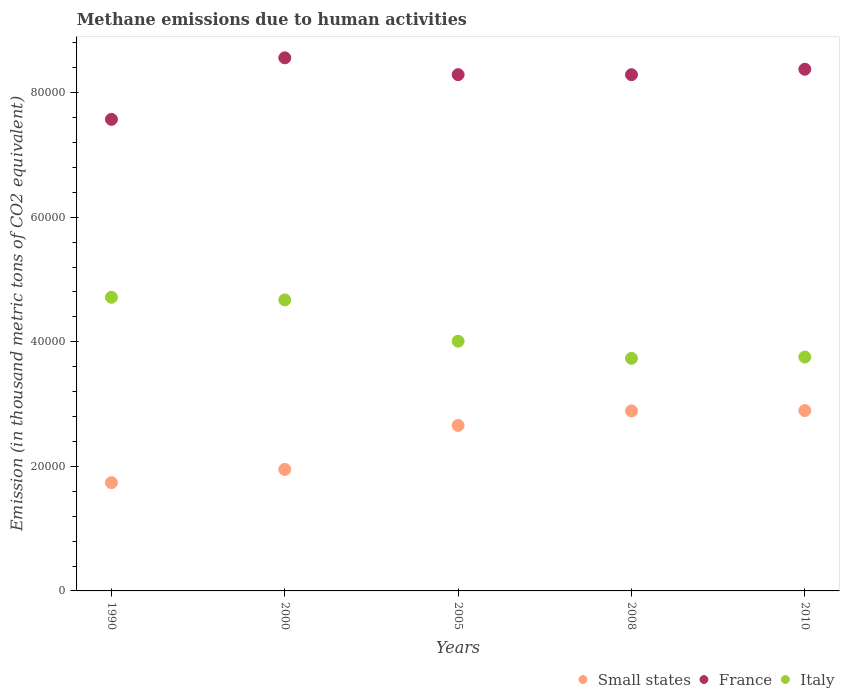How many different coloured dotlines are there?
Your answer should be compact. 3. Is the number of dotlines equal to the number of legend labels?
Keep it short and to the point. Yes. What is the amount of methane emitted in France in 2010?
Provide a short and direct response. 8.38e+04. Across all years, what is the maximum amount of methane emitted in Small states?
Give a very brief answer. 2.90e+04. Across all years, what is the minimum amount of methane emitted in Italy?
Provide a succinct answer. 3.73e+04. In which year was the amount of methane emitted in France maximum?
Provide a short and direct response. 2000. In which year was the amount of methane emitted in Small states minimum?
Offer a terse response. 1990. What is the total amount of methane emitted in Italy in the graph?
Your answer should be compact. 2.09e+05. What is the difference between the amount of methane emitted in France in 2000 and that in 2008?
Provide a succinct answer. 2710.3. What is the difference between the amount of methane emitted in Small states in 2005 and the amount of methane emitted in Italy in 2000?
Keep it short and to the point. -2.02e+04. What is the average amount of methane emitted in Italy per year?
Ensure brevity in your answer.  4.18e+04. In the year 1990, what is the difference between the amount of methane emitted in Italy and amount of methane emitted in France?
Make the answer very short. -2.86e+04. What is the ratio of the amount of methane emitted in Italy in 2000 to that in 2008?
Your answer should be compact. 1.25. Is the amount of methane emitted in France in 1990 less than that in 2010?
Provide a short and direct response. Yes. Is the difference between the amount of methane emitted in Italy in 1990 and 2008 greater than the difference between the amount of methane emitted in France in 1990 and 2008?
Offer a very short reply. Yes. What is the difference between the highest and the second highest amount of methane emitted in France?
Make the answer very short. 1835.2. What is the difference between the highest and the lowest amount of methane emitted in Small states?
Your answer should be compact. 1.16e+04. Is it the case that in every year, the sum of the amount of methane emitted in Italy and amount of methane emitted in France  is greater than the amount of methane emitted in Small states?
Give a very brief answer. Yes. Does the amount of methane emitted in France monotonically increase over the years?
Provide a short and direct response. No. Is the amount of methane emitted in France strictly less than the amount of methane emitted in Italy over the years?
Your answer should be very brief. No. How many dotlines are there?
Keep it short and to the point. 3. Does the graph contain grids?
Ensure brevity in your answer.  No. What is the title of the graph?
Keep it short and to the point. Methane emissions due to human activities. What is the label or title of the Y-axis?
Offer a very short reply. Emission (in thousand metric tons of CO2 equivalent). What is the Emission (in thousand metric tons of CO2 equivalent) in Small states in 1990?
Provide a short and direct response. 1.74e+04. What is the Emission (in thousand metric tons of CO2 equivalent) in France in 1990?
Provide a short and direct response. 7.57e+04. What is the Emission (in thousand metric tons of CO2 equivalent) of Italy in 1990?
Offer a terse response. 4.71e+04. What is the Emission (in thousand metric tons of CO2 equivalent) in Small states in 2000?
Make the answer very short. 1.95e+04. What is the Emission (in thousand metric tons of CO2 equivalent) in France in 2000?
Make the answer very short. 8.56e+04. What is the Emission (in thousand metric tons of CO2 equivalent) in Italy in 2000?
Your response must be concise. 4.67e+04. What is the Emission (in thousand metric tons of CO2 equivalent) in Small states in 2005?
Ensure brevity in your answer.  2.66e+04. What is the Emission (in thousand metric tons of CO2 equivalent) of France in 2005?
Keep it short and to the point. 8.29e+04. What is the Emission (in thousand metric tons of CO2 equivalent) in Italy in 2005?
Provide a short and direct response. 4.01e+04. What is the Emission (in thousand metric tons of CO2 equivalent) of Small states in 2008?
Ensure brevity in your answer.  2.89e+04. What is the Emission (in thousand metric tons of CO2 equivalent) of France in 2008?
Ensure brevity in your answer.  8.29e+04. What is the Emission (in thousand metric tons of CO2 equivalent) in Italy in 2008?
Offer a very short reply. 3.73e+04. What is the Emission (in thousand metric tons of CO2 equivalent) in Small states in 2010?
Keep it short and to the point. 2.90e+04. What is the Emission (in thousand metric tons of CO2 equivalent) in France in 2010?
Offer a very short reply. 8.38e+04. What is the Emission (in thousand metric tons of CO2 equivalent) in Italy in 2010?
Ensure brevity in your answer.  3.75e+04. Across all years, what is the maximum Emission (in thousand metric tons of CO2 equivalent) of Small states?
Keep it short and to the point. 2.90e+04. Across all years, what is the maximum Emission (in thousand metric tons of CO2 equivalent) in France?
Your answer should be very brief. 8.56e+04. Across all years, what is the maximum Emission (in thousand metric tons of CO2 equivalent) in Italy?
Provide a succinct answer. 4.71e+04. Across all years, what is the minimum Emission (in thousand metric tons of CO2 equivalent) in Small states?
Provide a succinct answer. 1.74e+04. Across all years, what is the minimum Emission (in thousand metric tons of CO2 equivalent) in France?
Provide a succinct answer. 7.57e+04. Across all years, what is the minimum Emission (in thousand metric tons of CO2 equivalent) in Italy?
Provide a short and direct response. 3.73e+04. What is the total Emission (in thousand metric tons of CO2 equivalent) in Small states in the graph?
Offer a very short reply. 1.21e+05. What is the total Emission (in thousand metric tons of CO2 equivalent) of France in the graph?
Provide a short and direct response. 4.11e+05. What is the total Emission (in thousand metric tons of CO2 equivalent) of Italy in the graph?
Your response must be concise. 2.09e+05. What is the difference between the Emission (in thousand metric tons of CO2 equivalent) in Small states in 1990 and that in 2000?
Offer a terse response. -2132.9. What is the difference between the Emission (in thousand metric tons of CO2 equivalent) of France in 1990 and that in 2000?
Your answer should be compact. -9878.9. What is the difference between the Emission (in thousand metric tons of CO2 equivalent) in Italy in 1990 and that in 2000?
Provide a short and direct response. 418.9. What is the difference between the Emission (in thousand metric tons of CO2 equivalent) in Small states in 1990 and that in 2005?
Give a very brief answer. -9189.8. What is the difference between the Emission (in thousand metric tons of CO2 equivalent) of France in 1990 and that in 2005?
Make the answer very short. -7175.9. What is the difference between the Emission (in thousand metric tons of CO2 equivalent) in Italy in 1990 and that in 2005?
Offer a very short reply. 7054.5. What is the difference between the Emission (in thousand metric tons of CO2 equivalent) in Small states in 1990 and that in 2008?
Make the answer very short. -1.15e+04. What is the difference between the Emission (in thousand metric tons of CO2 equivalent) in France in 1990 and that in 2008?
Your answer should be compact. -7168.6. What is the difference between the Emission (in thousand metric tons of CO2 equivalent) of Italy in 1990 and that in 2008?
Keep it short and to the point. 9804.1. What is the difference between the Emission (in thousand metric tons of CO2 equivalent) in Small states in 1990 and that in 2010?
Provide a short and direct response. -1.16e+04. What is the difference between the Emission (in thousand metric tons of CO2 equivalent) in France in 1990 and that in 2010?
Your response must be concise. -8043.7. What is the difference between the Emission (in thousand metric tons of CO2 equivalent) in Italy in 1990 and that in 2010?
Offer a very short reply. 9595.9. What is the difference between the Emission (in thousand metric tons of CO2 equivalent) in Small states in 2000 and that in 2005?
Your answer should be very brief. -7056.9. What is the difference between the Emission (in thousand metric tons of CO2 equivalent) in France in 2000 and that in 2005?
Your answer should be compact. 2703. What is the difference between the Emission (in thousand metric tons of CO2 equivalent) in Italy in 2000 and that in 2005?
Ensure brevity in your answer.  6635.6. What is the difference between the Emission (in thousand metric tons of CO2 equivalent) of Small states in 2000 and that in 2008?
Keep it short and to the point. -9393.1. What is the difference between the Emission (in thousand metric tons of CO2 equivalent) of France in 2000 and that in 2008?
Your answer should be very brief. 2710.3. What is the difference between the Emission (in thousand metric tons of CO2 equivalent) in Italy in 2000 and that in 2008?
Your answer should be compact. 9385.2. What is the difference between the Emission (in thousand metric tons of CO2 equivalent) of Small states in 2000 and that in 2010?
Keep it short and to the point. -9444.8. What is the difference between the Emission (in thousand metric tons of CO2 equivalent) of France in 2000 and that in 2010?
Your answer should be very brief. 1835.2. What is the difference between the Emission (in thousand metric tons of CO2 equivalent) of Italy in 2000 and that in 2010?
Ensure brevity in your answer.  9177. What is the difference between the Emission (in thousand metric tons of CO2 equivalent) in Small states in 2005 and that in 2008?
Ensure brevity in your answer.  -2336.2. What is the difference between the Emission (in thousand metric tons of CO2 equivalent) in France in 2005 and that in 2008?
Keep it short and to the point. 7.3. What is the difference between the Emission (in thousand metric tons of CO2 equivalent) in Italy in 2005 and that in 2008?
Make the answer very short. 2749.6. What is the difference between the Emission (in thousand metric tons of CO2 equivalent) of Small states in 2005 and that in 2010?
Give a very brief answer. -2387.9. What is the difference between the Emission (in thousand metric tons of CO2 equivalent) of France in 2005 and that in 2010?
Make the answer very short. -867.8. What is the difference between the Emission (in thousand metric tons of CO2 equivalent) of Italy in 2005 and that in 2010?
Give a very brief answer. 2541.4. What is the difference between the Emission (in thousand metric tons of CO2 equivalent) in Small states in 2008 and that in 2010?
Give a very brief answer. -51.7. What is the difference between the Emission (in thousand metric tons of CO2 equivalent) in France in 2008 and that in 2010?
Ensure brevity in your answer.  -875.1. What is the difference between the Emission (in thousand metric tons of CO2 equivalent) of Italy in 2008 and that in 2010?
Offer a very short reply. -208.2. What is the difference between the Emission (in thousand metric tons of CO2 equivalent) of Small states in 1990 and the Emission (in thousand metric tons of CO2 equivalent) of France in 2000?
Make the answer very short. -6.82e+04. What is the difference between the Emission (in thousand metric tons of CO2 equivalent) in Small states in 1990 and the Emission (in thousand metric tons of CO2 equivalent) in Italy in 2000?
Offer a terse response. -2.93e+04. What is the difference between the Emission (in thousand metric tons of CO2 equivalent) in France in 1990 and the Emission (in thousand metric tons of CO2 equivalent) in Italy in 2000?
Offer a terse response. 2.90e+04. What is the difference between the Emission (in thousand metric tons of CO2 equivalent) in Small states in 1990 and the Emission (in thousand metric tons of CO2 equivalent) in France in 2005?
Offer a very short reply. -6.55e+04. What is the difference between the Emission (in thousand metric tons of CO2 equivalent) of Small states in 1990 and the Emission (in thousand metric tons of CO2 equivalent) of Italy in 2005?
Keep it short and to the point. -2.27e+04. What is the difference between the Emission (in thousand metric tons of CO2 equivalent) in France in 1990 and the Emission (in thousand metric tons of CO2 equivalent) in Italy in 2005?
Keep it short and to the point. 3.56e+04. What is the difference between the Emission (in thousand metric tons of CO2 equivalent) in Small states in 1990 and the Emission (in thousand metric tons of CO2 equivalent) in France in 2008?
Keep it short and to the point. -6.55e+04. What is the difference between the Emission (in thousand metric tons of CO2 equivalent) in Small states in 1990 and the Emission (in thousand metric tons of CO2 equivalent) in Italy in 2008?
Ensure brevity in your answer.  -2.00e+04. What is the difference between the Emission (in thousand metric tons of CO2 equivalent) of France in 1990 and the Emission (in thousand metric tons of CO2 equivalent) of Italy in 2008?
Offer a very short reply. 3.84e+04. What is the difference between the Emission (in thousand metric tons of CO2 equivalent) in Small states in 1990 and the Emission (in thousand metric tons of CO2 equivalent) in France in 2010?
Provide a succinct answer. -6.64e+04. What is the difference between the Emission (in thousand metric tons of CO2 equivalent) of Small states in 1990 and the Emission (in thousand metric tons of CO2 equivalent) of Italy in 2010?
Give a very brief answer. -2.02e+04. What is the difference between the Emission (in thousand metric tons of CO2 equivalent) of France in 1990 and the Emission (in thousand metric tons of CO2 equivalent) of Italy in 2010?
Your response must be concise. 3.82e+04. What is the difference between the Emission (in thousand metric tons of CO2 equivalent) of Small states in 2000 and the Emission (in thousand metric tons of CO2 equivalent) of France in 2005?
Your answer should be very brief. -6.34e+04. What is the difference between the Emission (in thousand metric tons of CO2 equivalent) of Small states in 2000 and the Emission (in thousand metric tons of CO2 equivalent) of Italy in 2005?
Give a very brief answer. -2.06e+04. What is the difference between the Emission (in thousand metric tons of CO2 equivalent) of France in 2000 and the Emission (in thousand metric tons of CO2 equivalent) of Italy in 2005?
Offer a terse response. 4.55e+04. What is the difference between the Emission (in thousand metric tons of CO2 equivalent) in Small states in 2000 and the Emission (in thousand metric tons of CO2 equivalent) in France in 2008?
Your answer should be compact. -6.34e+04. What is the difference between the Emission (in thousand metric tons of CO2 equivalent) of Small states in 2000 and the Emission (in thousand metric tons of CO2 equivalent) of Italy in 2008?
Make the answer very short. -1.78e+04. What is the difference between the Emission (in thousand metric tons of CO2 equivalent) in France in 2000 and the Emission (in thousand metric tons of CO2 equivalent) in Italy in 2008?
Your answer should be very brief. 4.82e+04. What is the difference between the Emission (in thousand metric tons of CO2 equivalent) in Small states in 2000 and the Emission (in thousand metric tons of CO2 equivalent) in France in 2010?
Your answer should be compact. -6.42e+04. What is the difference between the Emission (in thousand metric tons of CO2 equivalent) in Small states in 2000 and the Emission (in thousand metric tons of CO2 equivalent) in Italy in 2010?
Your answer should be very brief. -1.80e+04. What is the difference between the Emission (in thousand metric tons of CO2 equivalent) of France in 2000 and the Emission (in thousand metric tons of CO2 equivalent) of Italy in 2010?
Make the answer very short. 4.80e+04. What is the difference between the Emission (in thousand metric tons of CO2 equivalent) of Small states in 2005 and the Emission (in thousand metric tons of CO2 equivalent) of France in 2008?
Offer a terse response. -5.63e+04. What is the difference between the Emission (in thousand metric tons of CO2 equivalent) in Small states in 2005 and the Emission (in thousand metric tons of CO2 equivalent) in Italy in 2008?
Ensure brevity in your answer.  -1.08e+04. What is the difference between the Emission (in thousand metric tons of CO2 equivalent) in France in 2005 and the Emission (in thousand metric tons of CO2 equivalent) in Italy in 2008?
Offer a terse response. 4.55e+04. What is the difference between the Emission (in thousand metric tons of CO2 equivalent) of Small states in 2005 and the Emission (in thousand metric tons of CO2 equivalent) of France in 2010?
Offer a very short reply. -5.72e+04. What is the difference between the Emission (in thousand metric tons of CO2 equivalent) of Small states in 2005 and the Emission (in thousand metric tons of CO2 equivalent) of Italy in 2010?
Your answer should be very brief. -1.10e+04. What is the difference between the Emission (in thousand metric tons of CO2 equivalent) of France in 2005 and the Emission (in thousand metric tons of CO2 equivalent) of Italy in 2010?
Your response must be concise. 4.53e+04. What is the difference between the Emission (in thousand metric tons of CO2 equivalent) in Small states in 2008 and the Emission (in thousand metric tons of CO2 equivalent) in France in 2010?
Your answer should be compact. -5.48e+04. What is the difference between the Emission (in thousand metric tons of CO2 equivalent) of Small states in 2008 and the Emission (in thousand metric tons of CO2 equivalent) of Italy in 2010?
Offer a terse response. -8643.2. What is the difference between the Emission (in thousand metric tons of CO2 equivalent) of France in 2008 and the Emission (in thousand metric tons of CO2 equivalent) of Italy in 2010?
Keep it short and to the point. 4.53e+04. What is the average Emission (in thousand metric tons of CO2 equivalent) in Small states per year?
Make the answer very short. 2.43e+04. What is the average Emission (in thousand metric tons of CO2 equivalent) in France per year?
Your answer should be compact. 8.22e+04. What is the average Emission (in thousand metric tons of CO2 equivalent) in Italy per year?
Ensure brevity in your answer.  4.18e+04. In the year 1990, what is the difference between the Emission (in thousand metric tons of CO2 equivalent) in Small states and Emission (in thousand metric tons of CO2 equivalent) in France?
Provide a succinct answer. -5.83e+04. In the year 1990, what is the difference between the Emission (in thousand metric tons of CO2 equivalent) in Small states and Emission (in thousand metric tons of CO2 equivalent) in Italy?
Your answer should be very brief. -2.98e+04. In the year 1990, what is the difference between the Emission (in thousand metric tons of CO2 equivalent) in France and Emission (in thousand metric tons of CO2 equivalent) in Italy?
Give a very brief answer. 2.86e+04. In the year 2000, what is the difference between the Emission (in thousand metric tons of CO2 equivalent) of Small states and Emission (in thousand metric tons of CO2 equivalent) of France?
Provide a succinct answer. -6.61e+04. In the year 2000, what is the difference between the Emission (in thousand metric tons of CO2 equivalent) in Small states and Emission (in thousand metric tons of CO2 equivalent) in Italy?
Your response must be concise. -2.72e+04. In the year 2000, what is the difference between the Emission (in thousand metric tons of CO2 equivalent) in France and Emission (in thousand metric tons of CO2 equivalent) in Italy?
Provide a succinct answer. 3.89e+04. In the year 2005, what is the difference between the Emission (in thousand metric tons of CO2 equivalent) of Small states and Emission (in thousand metric tons of CO2 equivalent) of France?
Ensure brevity in your answer.  -5.63e+04. In the year 2005, what is the difference between the Emission (in thousand metric tons of CO2 equivalent) of Small states and Emission (in thousand metric tons of CO2 equivalent) of Italy?
Make the answer very short. -1.35e+04. In the year 2005, what is the difference between the Emission (in thousand metric tons of CO2 equivalent) in France and Emission (in thousand metric tons of CO2 equivalent) in Italy?
Make the answer very short. 4.28e+04. In the year 2008, what is the difference between the Emission (in thousand metric tons of CO2 equivalent) of Small states and Emission (in thousand metric tons of CO2 equivalent) of France?
Keep it short and to the point. -5.40e+04. In the year 2008, what is the difference between the Emission (in thousand metric tons of CO2 equivalent) of Small states and Emission (in thousand metric tons of CO2 equivalent) of Italy?
Offer a terse response. -8435. In the year 2008, what is the difference between the Emission (in thousand metric tons of CO2 equivalent) in France and Emission (in thousand metric tons of CO2 equivalent) in Italy?
Your answer should be compact. 4.55e+04. In the year 2010, what is the difference between the Emission (in thousand metric tons of CO2 equivalent) in Small states and Emission (in thousand metric tons of CO2 equivalent) in France?
Make the answer very short. -5.48e+04. In the year 2010, what is the difference between the Emission (in thousand metric tons of CO2 equivalent) in Small states and Emission (in thousand metric tons of CO2 equivalent) in Italy?
Your answer should be very brief. -8591.5. In the year 2010, what is the difference between the Emission (in thousand metric tons of CO2 equivalent) in France and Emission (in thousand metric tons of CO2 equivalent) in Italy?
Make the answer very short. 4.62e+04. What is the ratio of the Emission (in thousand metric tons of CO2 equivalent) in Small states in 1990 to that in 2000?
Your response must be concise. 0.89. What is the ratio of the Emission (in thousand metric tons of CO2 equivalent) of France in 1990 to that in 2000?
Your response must be concise. 0.88. What is the ratio of the Emission (in thousand metric tons of CO2 equivalent) of Italy in 1990 to that in 2000?
Your answer should be compact. 1.01. What is the ratio of the Emission (in thousand metric tons of CO2 equivalent) in Small states in 1990 to that in 2005?
Provide a succinct answer. 0.65. What is the ratio of the Emission (in thousand metric tons of CO2 equivalent) in France in 1990 to that in 2005?
Provide a succinct answer. 0.91. What is the ratio of the Emission (in thousand metric tons of CO2 equivalent) of Italy in 1990 to that in 2005?
Your answer should be compact. 1.18. What is the ratio of the Emission (in thousand metric tons of CO2 equivalent) of Small states in 1990 to that in 2008?
Provide a short and direct response. 0.6. What is the ratio of the Emission (in thousand metric tons of CO2 equivalent) of France in 1990 to that in 2008?
Provide a short and direct response. 0.91. What is the ratio of the Emission (in thousand metric tons of CO2 equivalent) of Italy in 1990 to that in 2008?
Offer a terse response. 1.26. What is the ratio of the Emission (in thousand metric tons of CO2 equivalent) of Small states in 1990 to that in 2010?
Ensure brevity in your answer.  0.6. What is the ratio of the Emission (in thousand metric tons of CO2 equivalent) in France in 1990 to that in 2010?
Provide a succinct answer. 0.9. What is the ratio of the Emission (in thousand metric tons of CO2 equivalent) of Italy in 1990 to that in 2010?
Offer a very short reply. 1.26. What is the ratio of the Emission (in thousand metric tons of CO2 equivalent) of Small states in 2000 to that in 2005?
Offer a terse response. 0.73. What is the ratio of the Emission (in thousand metric tons of CO2 equivalent) in France in 2000 to that in 2005?
Ensure brevity in your answer.  1.03. What is the ratio of the Emission (in thousand metric tons of CO2 equivalent) in Italy in 2000 to that in 2005?
Keep it short and to the point. 1.17. What is the ratio of the Emission (in thousand metric tons of CO2 equivalent) of Small states in 2000 to that in 2008?
Make the answer very short. 0.68. What is the ratio of the Emission (in thousand metric tons of CO2 equivalent) of France in 2000 to that in 2008?
Your response must be concise. 1.03. What is the ratio of the Emission (in thousand metric tons of CO2 equivalent) of Italy in 2000 to that in 2008?
Offer a very short reply. 1.25. What is the ratio of the Emission (in thousand metric tons of CO2 equivalent) in Small states in 2000 to that in 2010?
Keep it short and to the point. 0.67. What is the ratio of the Emission (in thousand metric tons of CO2 equivalent) of France in 2000 to that in 2010?
Offer a very short reply. 1.02. What is the ratio of the Emission (in thousand metric tons of CO2 equivalent) in Italy in 2000 to that in 2010?
Offer a terse response. 1.24. What is the ratio of the Emission (in thousand metric tons of CO2 equivalent) of Small states in 2005 to that in 2008?
Ensure brevity in your answer.  0.92. What is the ratio of the Emission (in thousand metric tons of CO2 equivalent) in France in 2005 to that in 2008?
Provide a short and direct response. 1. What is the ratio of the Emission (in thousand metric tons of CO2 equivalent) of Italy in 2005 to that in 2008?
Offer a terse response. 1.07. What is the ratio of the Emission (in thousand metric tons of CO2 equivalent) in Small states in 2005 to that in 2010?
Provide a short and direct response. 0.92. What is the ratio of the Emission (in thousand metric tons of CO2 equivalent) of Italy in 2005 to that in 2010?
Ensure brevity in your answer.  1.07. What is the ratio of the Emission (in thousand metric tons of CO2 equivalent) in France in 2008 to that in 2010?
Provide a succinct answer. 0.99. What is the difference between the highest and the second highest Emission (in thousand metric tons of CO2 equivalent) in Small states?
Give a very brief answer. 51.7. What is the difference between the highest and the second highest Emission (in thousand metric tons of CO2 equivalent) in France?
Your answer should be very brief. 1835.2. What is the difference between the highest and the second highest Emission (in thousand metric tons of CO2 equivalent) in Italy?
Ensure brevity in your answer.  418.9. What is the difference between the highest and the lowest Emission (in thousand metric tons of CO2 equivalent) in Small states?
Provide a succinct answer. 1.16e+04. What is the difference between the highest and the lowest Emission (in thousand metric tons of CO2 equivalent) in France?
Offer a terse response. 9878.9. What is the difference between the highest and the lowest Emission (in thousand metric tons of CO2 equivalent) of Italy?
Provide a short and direct response. 9804.1. 